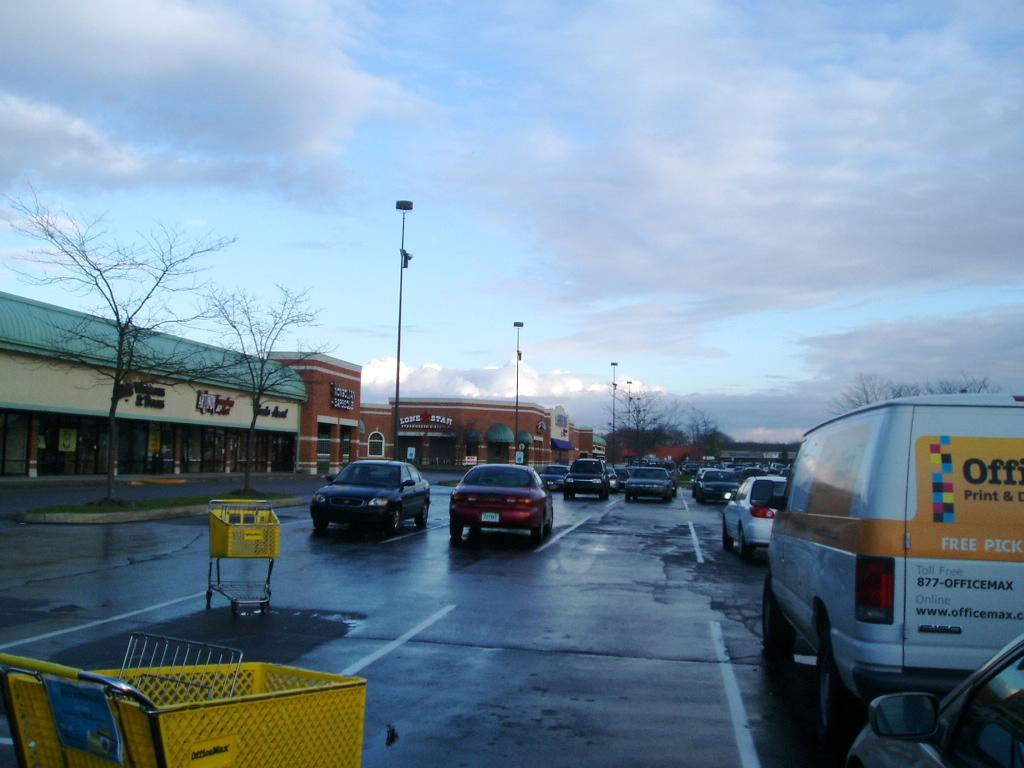What is present on the road in the image? There are vehicles and trays on the road in the image. What can be seen in the background of the image? There are trees, poles, and shops in the background. What is visible in the sky? The sky is visible in the image. How many steps are required to reach the shops from the trays on the road? There is no information about steps or a specific distance to the shops in the image. Can you describe the way the trays are being pushed on the road? There is no indication of the trays being pushed in the image; they are simply present on the road. 